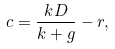<formula> <loc_0><loc_0><loc_500><loc_500>c = \frac { k D } { k + g } - r ,</formula> 